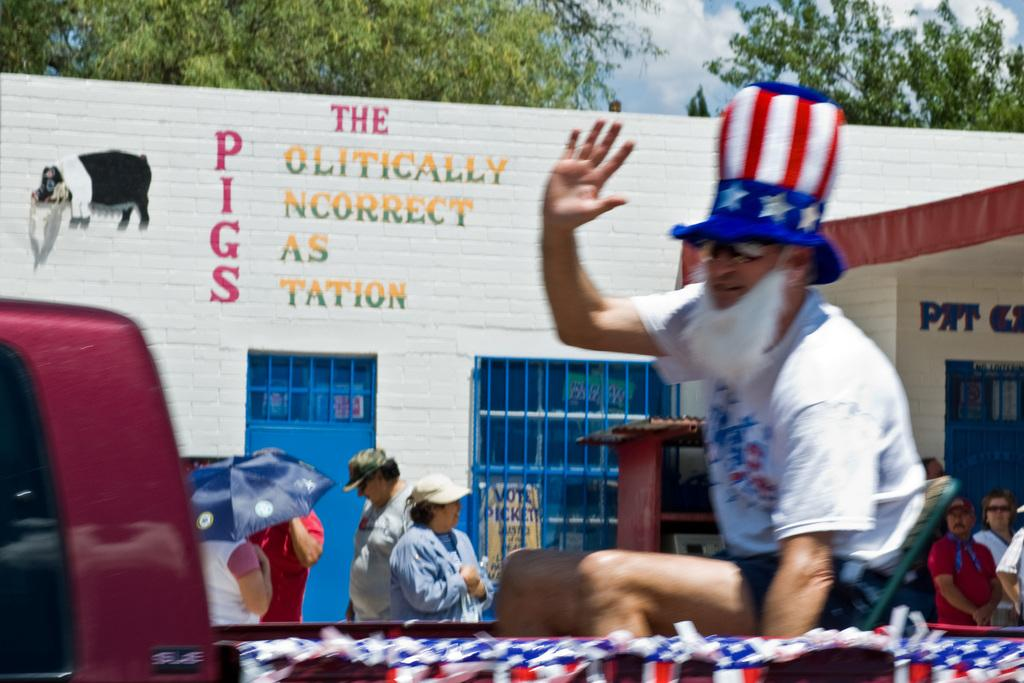<image>
Offer a succinct explanation of the picture presented. A man wearing a tall red white and blue hat and white beard rides on a truck bed waving as he passes a building with PIGS written on it. 